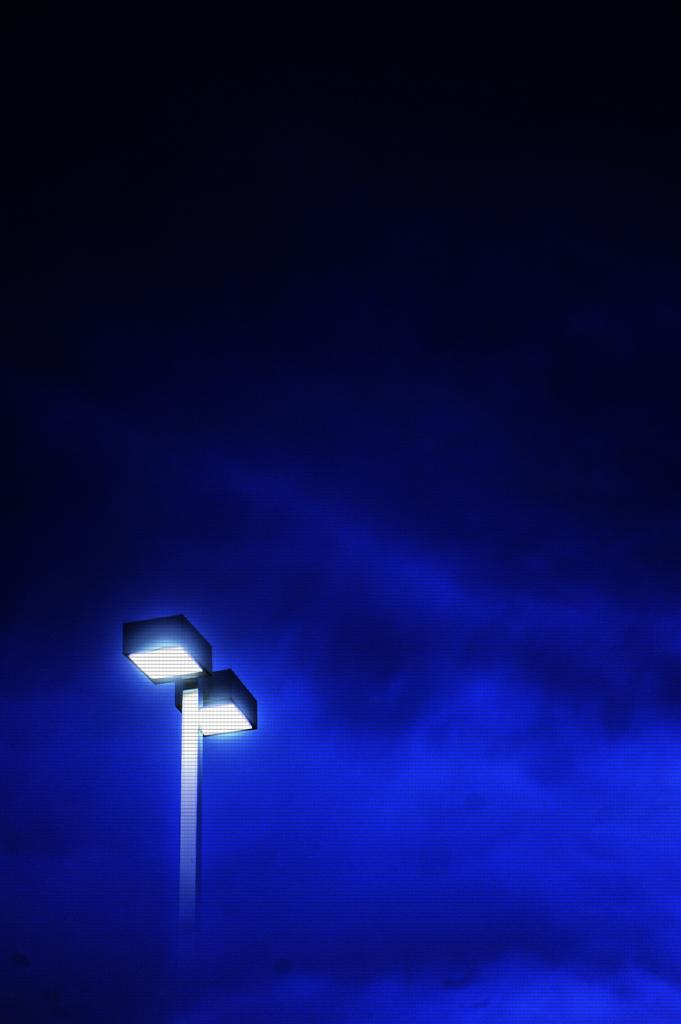What is the main object in the image? There is a metal pole in the image. What is attached to the top of the metal pole? There are two street lights on top of the pole. Can you describe the background of the image? The background of the image is black and blue in color. What type of apparel is the clover wearing in the image? There is no clover or apparel present in the image. How many trips can be taken using the metal pole in the image? The metal pole is not a mode of transportation, so it cannot be used for taking trips. 